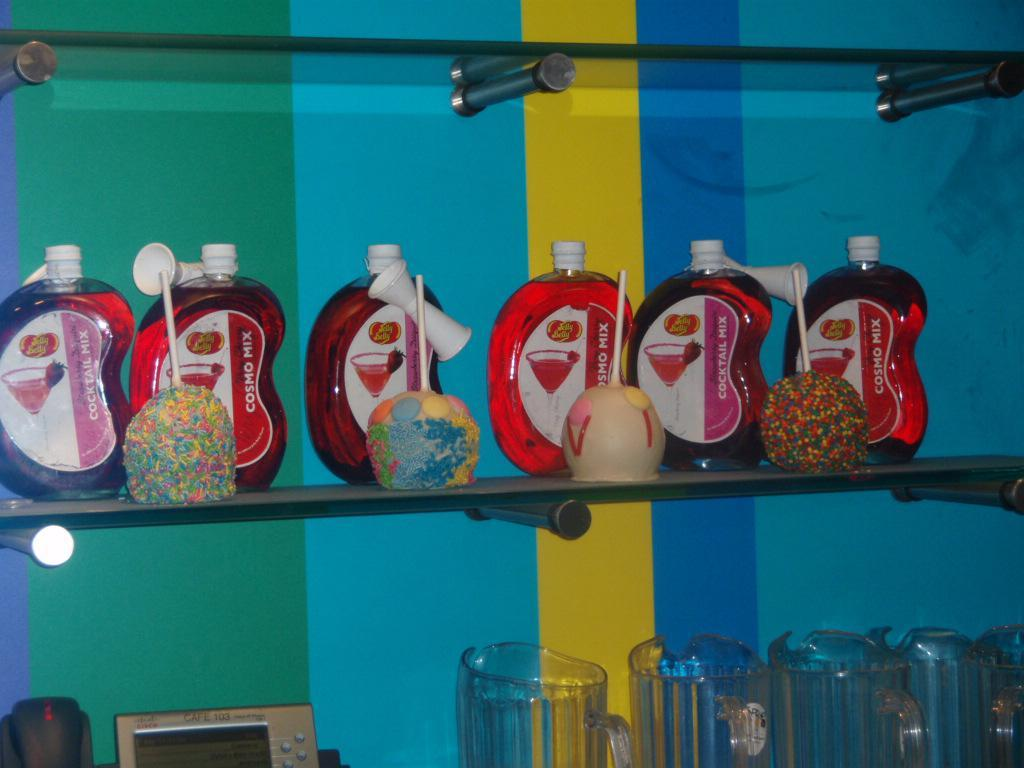What types of items are in the image? There are different bottles, lollipops, and glass jars in the image. How are the items arranged in the image? The bottles, lollipops, and glass jars are in a rack. What other object can be seen in the image? There is a digital machine in the image. What is visible in the background of the image? There is a wall in the background of the image. What is the tendency of the lollipops to connect with the support in the image? There is no mention of a tendency, connection, or support in the image. The lollipops are simply arranged in a rack with the other items. 